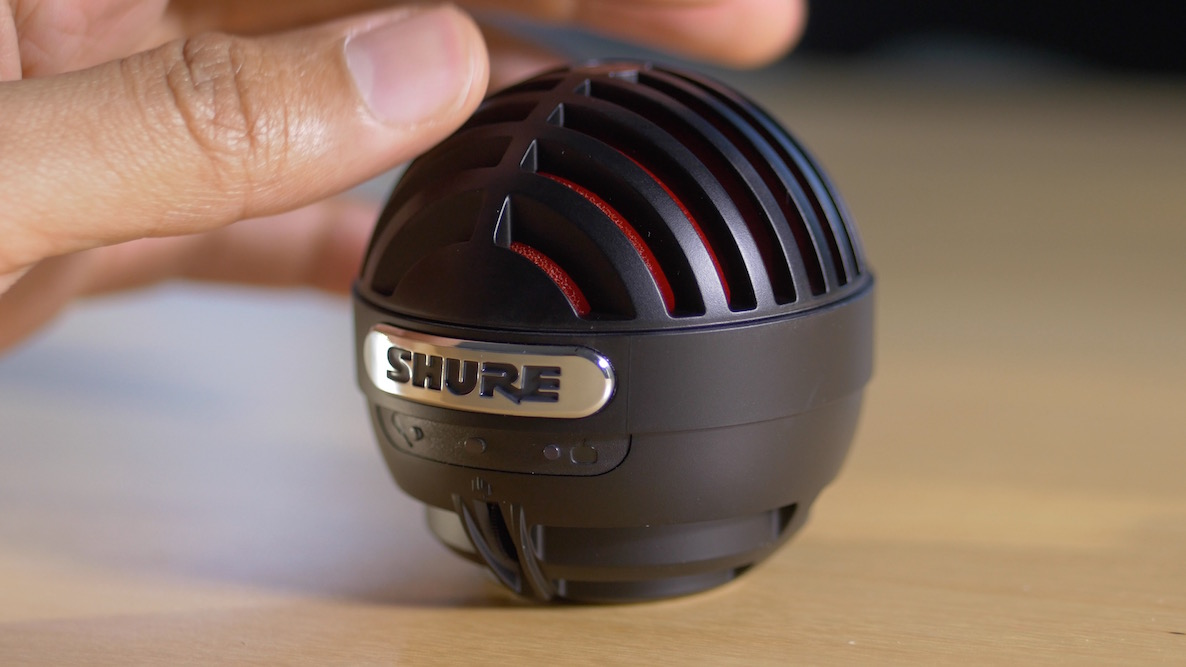What type of microphone is this, and in what scenarios might it typically be used? This is a Shure dynamic microphone, recognizable by its distinctive mesh grille and compact design. It's often used in live performance settings due to its durability and ability to handle high sound pressure levels without distortion. This type of microphone is also favored by podcasters and radio hosts for its rich vocal reproduction and effective background noise rejection. 